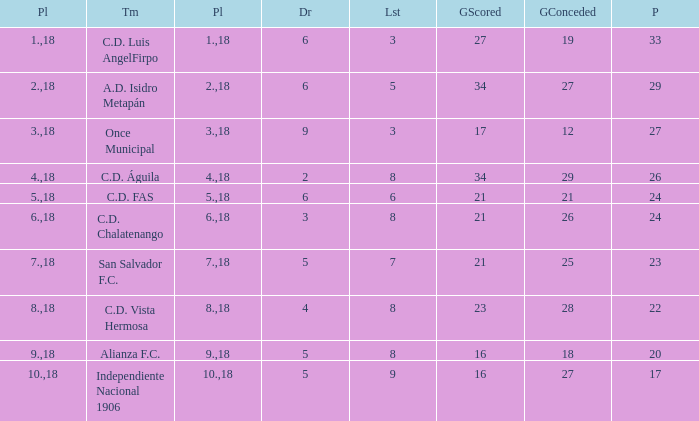What is the lowest amount of goals scored that has more than 19 goal conceded and played less than 18? None. 